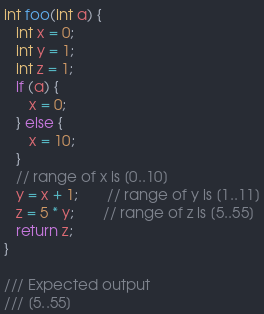Convert code to text. <code><loc_0><loc_0><loc_500><loc_500><_C_>int foo(int a) {
   int x = 0;
   int y = 1;
   int z = 1;
   if (a) {
      x = 0;
   } else {
      x = 10;
   }
   // range of x is [0..10] 
   y = x + 1;       // range of y is [1..11]
   z = 5 * y;       // range of z is [5..55]
   return z;
}

/// Expected output
/// [5..55]
</code> 